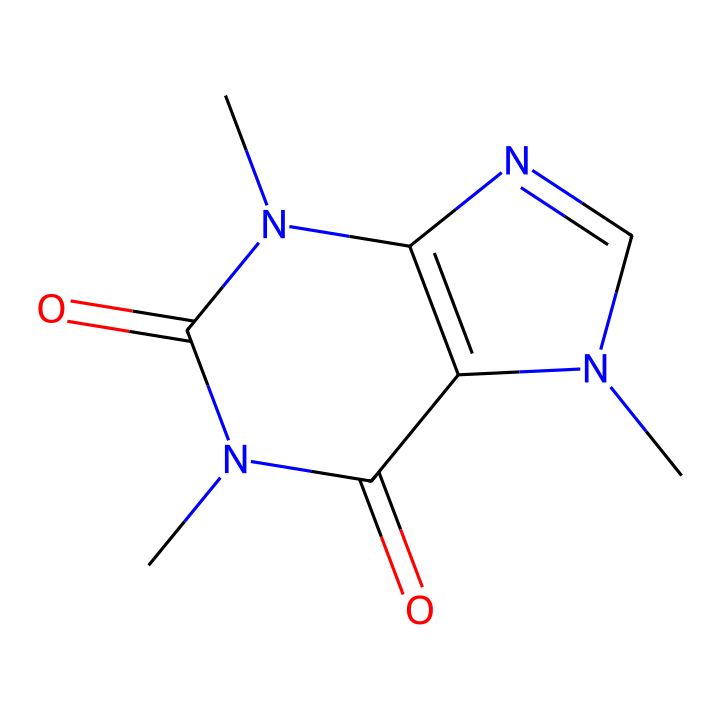How many nitrogen atoms are present in caffeine? By analyzing the SMILES structure, we identify the nitrogen atoms represented by 'N'. In the structure provided, there are a total of four 'N' atoms.
Answer: four What is the molecular formula of caffeine? To derive the molecular formula, we count the number of each type of atom indicated in the SMILES notation: carbons (C), hydrogens (H), nitrogens (N), and oxygens (O). The molecular formula is C8H10N4O2.
Answer: C8H10N4O2 What type of chemical compound is caffeine classified as? The structure reveals multiple nitrogen atoms and a complex ring system, indicating that caffeine is an alkaloid. Alkaloids are typically derived from plant sources and have pharmacological effects.
Answer: alkaloid How does caffeine interact with the central nervous system? Caffeine's structure allows it to block adenosine receptors, preventing the onset of drowsiness. Its nitrogen-containing rings enable this interaction, which stimulates the central nervous system and increases alertness.
Answer: blocks adenosine receptors What role do the carbonyl groups play in caffeine's structure? Carbonyl groups (C=O), present in caffeine, contribute to the molecule's polarity and hydrogen bonding capabilities, enhancing its solubility in liquids like water, which is important for absorption in the body.
Answer: enhance solubility What is the primary physiological effect of caffeine when consumed in energy drinks? The energetic effect primarily arises from the inhibition of adenosine receptors, leading to increased alertness and decreased fatigue, thus aiding late-night tasks such as data analysis.
Answer: increased alertness 